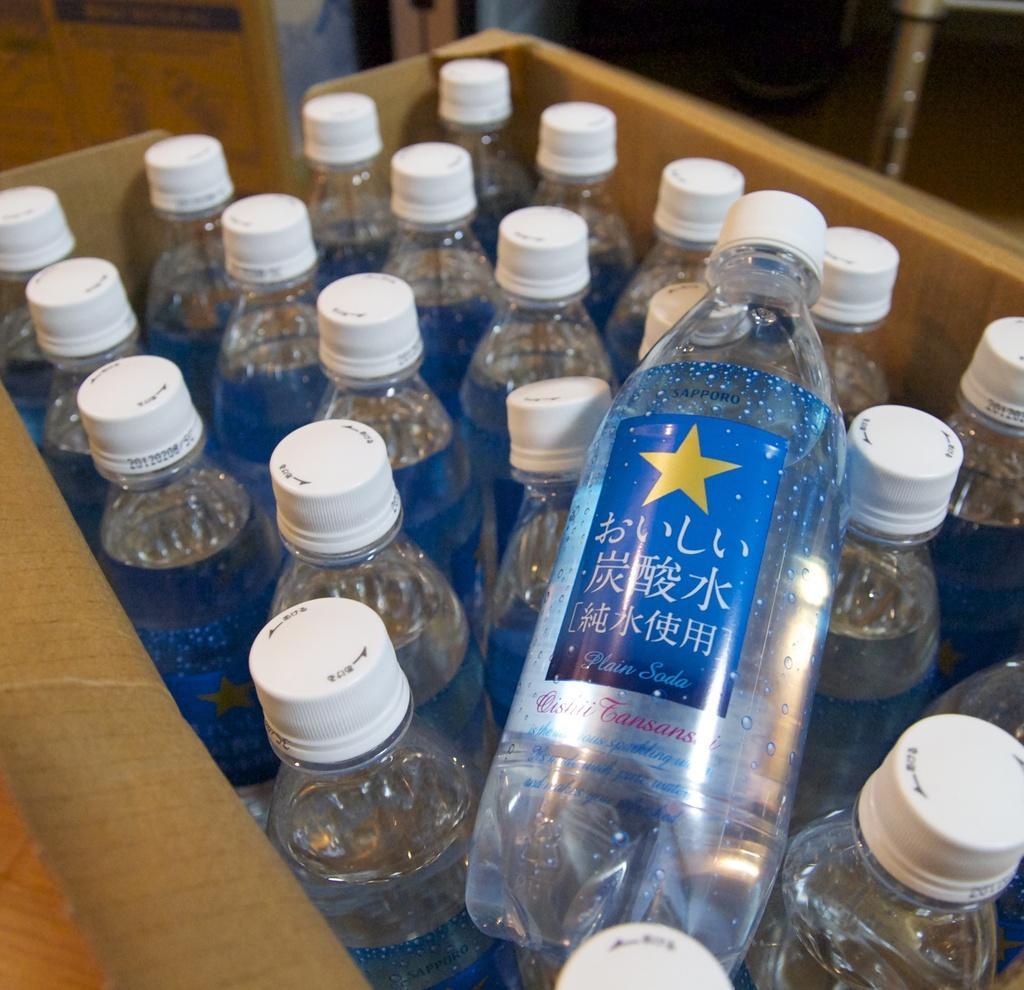Describe this image in one or two sentences. In this image I can see group of water bottles in a box. 